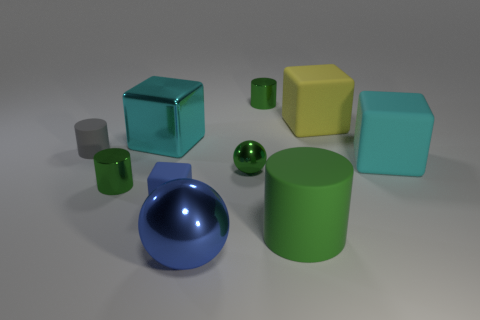Subtract all green spheres. How many green cylinders are left? 3 Subtract 1 cubes. How many cubes are left? 3 Subtract all yellow blocks. How many blocks are left? 3 Subtract all yellow cubes. How many cubes are left? 3 Subtract all gray cylinders. Subtract all gray cubes. How many cylinders are left? 3 Subtract all spheres. How many objects are left? 8 Add 3 big blue things. How many big blue things are left? 4 Add 6 small green cylinders. How many small green cylinders exist? 8 Subtract 1 blue spheres. How many objects are left? 9 Subtract all green rubber cylinders. Subtract all gray objects. How many objects are left? 8 